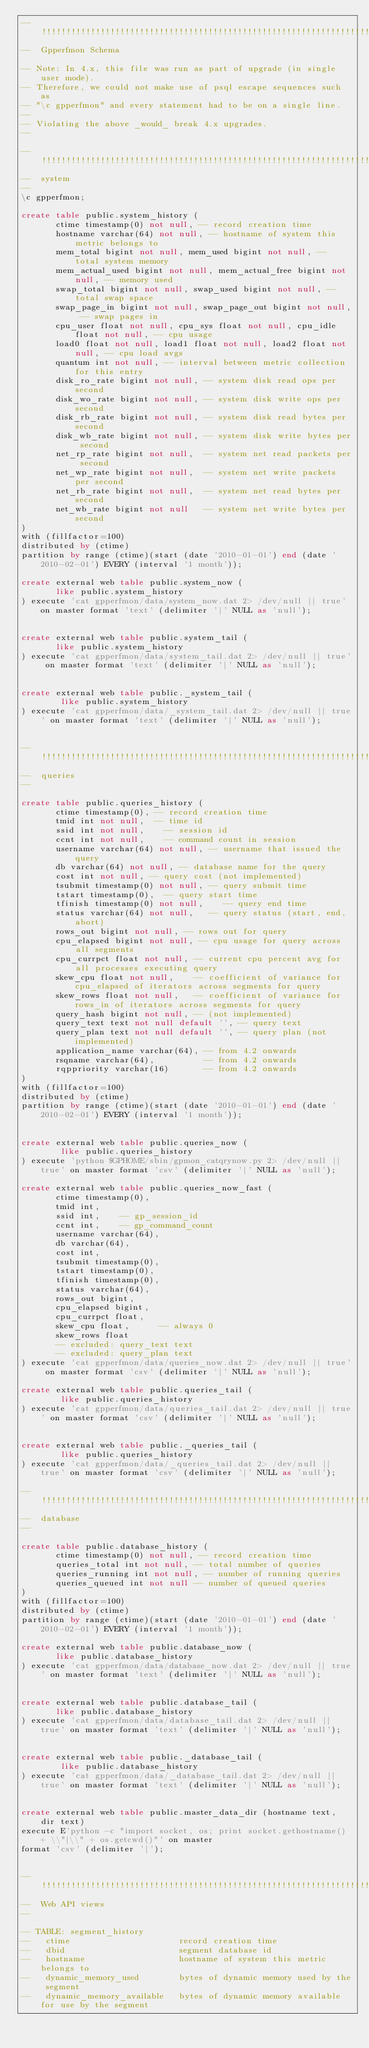<code> <loc_0><loc_0><loc_500><loc_500><_SQL_>--  !!!!!!!!!!!!!!!!!!!!!!!!!!!!!!!!!!!!!!!!!!!!!!!!!!!!!!!!!!!!!!!!!!!!!!!!!!!!!!!!!!!!!!!!!!!
--  Gpperfmon Schema

-- Note: In 4.x, this file was run as part of upgrade (in single user mode).
-- Therefore, we could not make use of psql escape sequences such as
-- "\c gpperfmon" and every statement had to be on a single line.
--
-- Violating the above _would_ break 4.x upgrades.
--

--  !!!!!!!!!!!!!!!!!!!!!!!!!!!!!!!!!!!!!!!!!!!!!!!!!!!!!!!!!!!!!!!!!!!!!!!!!!!!!!!!!!!!!!!!!!!
--  system
--
\c gpperfmon;

create table public.system_history (
       ctime timestamp(0) not null, -- record creation time
       hostname varchar(64) not null, -- hostname of system this metric belongs to
       mem_total bigint not null, mem_used bigint not null, -- total system memory
       mem_actual_used bigint not null, mem_actual_free bigint not null, -- memory used
       swap_total bigint not null, swap_used bigint not null, -- total swap space
       swap_page_in bigint not null, swap_page_out bigint not null, -- swap pages in
       cpu_user float not null, cpu_sys float not null, cpu_idle float not null, -- cpu usage
       load0 float not null, load1 float not null, load2 float not null, -- cpu load avgs
       quantum int not null, -- interval between metric collection for this entry
       disk_ro_rate bigint not null, -- system disk read ops per second
       disk_wo_rate bigint not null, -- system disk write ops per second
       disk_rb_rate bigint not null, -- system disk read bytes per second
       disk_wb_rate bigint not null, -- system disk write bytes per second
       net_rp_rate bigint not null,  -- system net read packets per second
       net_wp_rate bigint not null,  -- system net write packets per second
       net_rb_rate bigint not null,  -- system net read bytes per second
       net_wb_rate bigint not null   -- system net write bytes per second
) 
with (fillfactor=100)
distributed by (ctime)
partition by range (ctime)(start (date '2010-01-01') end (date '2010-02-01') EVERY (interval '1 month'));

create external web table public.system_now (
       like public.system_history
) execute 'cat gpperfmon/data/system_now.dat 2> /dev/null || true' on master format 'text' (delimiter '|' NULL as 'null');


create external web table public.system_tail (
       like public.system_history
) execute 'cat gpperfmon/data/system_tail.dat 2> /dev/null || true' on master format 'text' (delimiter '|' NULL as 'null');


create external web table public._system_tail (
        like public.system_history
) execute 'cat gpperfmon/data/_system_tail.dat 2> /dev/null || true' on master format 'text' (delimiter '|' NULL as 'null');


--  !!!!!!!!!!!!!!!!!!!!!!!!!!!!!!!!!!!!!!!!!!!!!!!!!!!!!!!!!!!!!!!!!!!!!!!!!!!!!!!!!!!!!!!!!!!
--  queries
--

create table public.queries_history (
       ctime timestamp(0), -- record creation time
       tmid int not null,  -- time id
       ssid int not null,    -- session id
       ccnt int not null,    -- command count in session
       username varchar(64) not null, -- username that issued the query
       db varchar(64) not null, -- database name for the query
       cost int not null, -- query cost (not implemented)
       tsubmit timestamp(0) not null, -- query submit time
       tstart timestamp(0),  -- query start time
       tfinish timestamp(0) not null,    -- query end time
       status varchar(64) not null,   -- query status (start, end, abort)
       rows_out bigint not null, -- rows out for query
       cpu_elapsed bigint not null, -- cpu usage for query across all segments
       cpu_currpct float not null, -- current cpu percent avg for all processes executing query
       skew_cpu float not null,    -- coefficient of variance for cpu_elapsed of iterators across segments for query
       skew_rows float not null,   -- coefficient of variance for rows_in of iterators across segments for query
       query_hash bigint not null, -- (not implemented)
       query_text text not null default '', -- query text
       query_plan text not null default '', -- query plan (not implemented)
       application_name varchar(64), -- from 4.2 onwards
       rsqname varchar(64),          -- from 4.2 onwards
       rqppriority varchar(16)       -- from 4.2 onwards
)
with (fillfactor=100)
distributed by (ctime)
partition by range (ctime)(start (date '2010-01-01') end (date '2010-02-01') EVERY (interval '1 month'));


create external web table public.queries_now (
        like public.queries_history
) execute 'python $GPHOME/sbin/gpmon_catqrynow.py 2> /dev/null || true' on master format 'csv' (delimiter '|' NULL as 'null');

create external web table public.queries_now_fast (
       ctime timestamp(0),
       tmid int,
       ssid int,    -- gp_session_id
       ccnt int,    -- gp_command_count
       username varchar(64),
       db varchar(64),
       cost int,
       tsubmit timestamp(0), 
       tstart timestamp(0), 
       tfinish timestamp(0),
       status varchar(64),
       rows_out bigint,
       cpu_elapsed bigint,
       cpu_currpct float,
       skew_cpu float,		-- always 0
       skew_rows float
       -- excluded: query_text text
       -- excluded: query_plan text
) execute 'cat gpperfmon/data/queries_now.dat 2> /dev/null || true' on master format 'csv' (delimiter '|' NULL as 'null');

create external web table public.queries_tail (
        like public.queries_history
) execute 'cat gpperfmon/data/queries_tail.dat 2> /dev/null || true' on master format 'csv' (delimiter '|' NULL as 'null');


create external web table public._queries_tail (
        like public.queries_history
) execute 'cat gpperfmon/data/_queries_tail.dat 2> /dev/null || true' on master format 'csv' (delimiter '|' NULL as 'null');

--  !!!!!!!!!!!!!!!!!!!!!!!!!!!!!!!!!!!!!!!!!!!!!!!!!!!!!!!!!!!!!!!!!!!!!!!!!!!!!!!!!!!!!!!!!!!
--  database
--

create table public.database_history (
       ctime timestamp(0) not null, -- record creation time
       queries_total int not null, -- total number of queries
       queries_running int not null, -- number of running queries
       queries_queued int not null -- number of queued queries
) 
with (fillfactor=100)
distributed by (ctime)
partition by range (ctime)(start (date '2010-01-01') end (date '2010-02-01') EVERY (interval '1 month'));

create external web table public.database_now (
       like public.database_history
) execute 'cat gpperfmon/data/database_now.dat 2> /dev/null || true' on master format 'text' (delimiter '|' NULL as 'null');


create external web table public.database_tail (
       like public.database_history
) execute 'cat gpperfmon/data/database_tail.dat 2> /dev/null || true' on master format 'text' (delimiter '|' NULL as 'null');


create external web table public._database_tail (
        like public.database_history
) execute 'cat gpperfmon/data/_database_tail.dat 2> /dev/null || true' on master format 'text' (delimiter '|' NULL as 'null');


create external web table public.master_data_dir (hostname text, dir text)
execute E'python -c "import socket, os; print socket.gethostname() + \\"|\\" + os.getcwd()"' on master
format 'csv' (delimiter '|');


--  !!!!!!!!!!!!!!!!!!!!!!!!!!!!!!!!!!!!!!!!!!!!!!!!!!!!!!!!!!!!!!!!!!!!!!!!!!!!!!!!!!!!!!!!!!!
--  Web API views
--

-- TABLE: segment_history
--   ctime                      record creation time
--   dbid                       segment database id
--   hostname                   hostname of system this metric belongs to
--   dynamic_memory_used        bytes of dynamic memory used by the segment
--   dynamic_memory_available   bytes of dynamic memory available for use by the segment</code> 